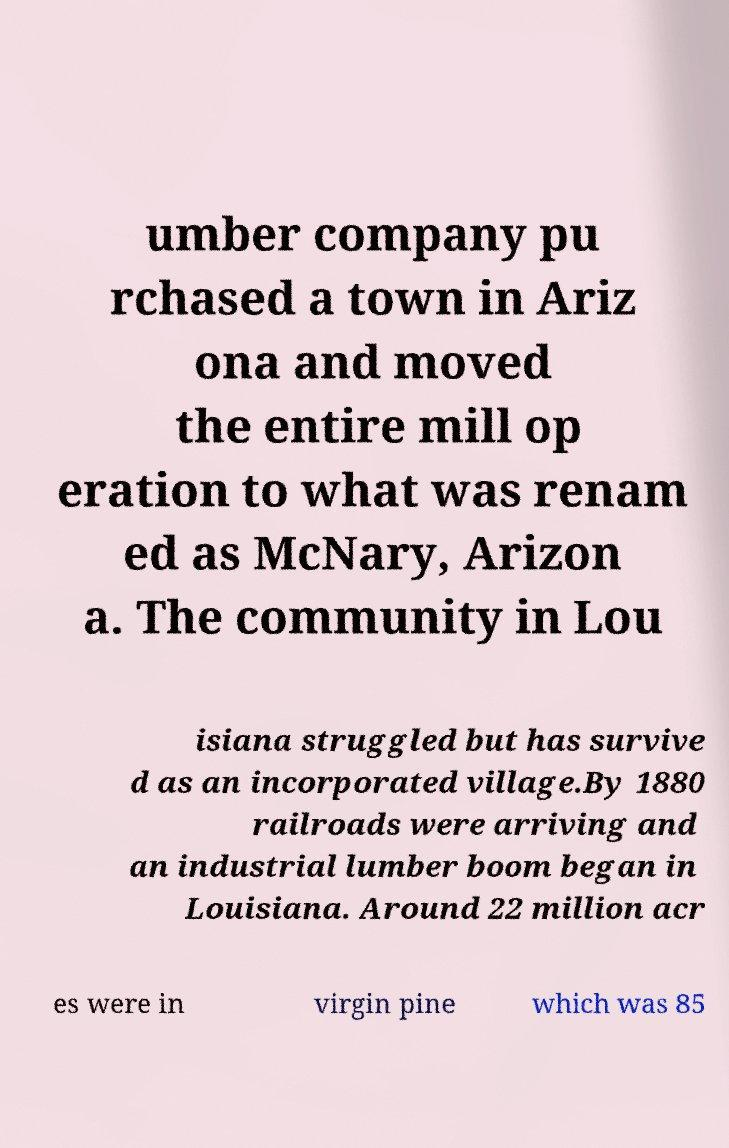Could you extract and type out the text from this image? umber company pu rchased a town in Ariz ona and moved the entire mill op eration to what was renam ed as McNary, Arizon a. The community in Lou isiana struggled but has survive d as an incorporated village.By 1880 railroads were arriving and an industrial lumber boom began in Louisiana. Around 22 million acr es were in virgin pine which was 85 